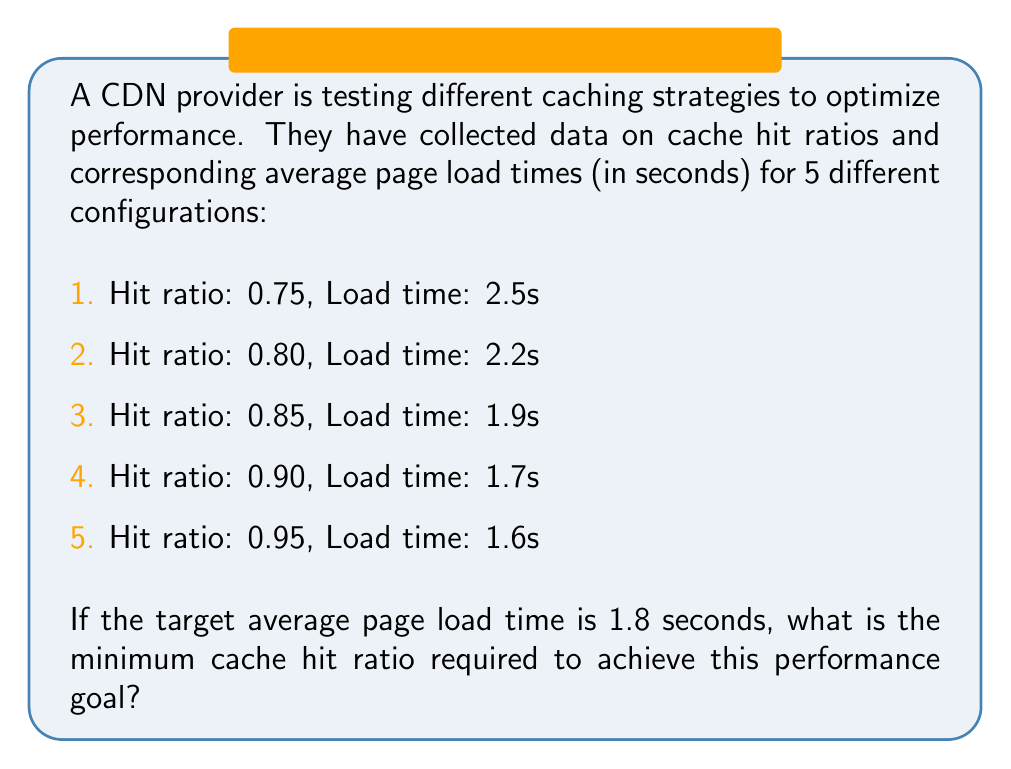What is the answer to this math problem? To solve this problem, we need to analyze the relationship between the cache hit ratio and the average page load time. Let's approach this step-by-step:

1. First, let's organize the data in ascending order of hit ratio:

   Hit Ratio (x) | Load Time (y)
   0.75          | 2.5s
   0.80          | 2.2s
   0.85          | 1.9s
   0.90          | 1.7s
   0.95          | 1.6s

2. We can see that as the hit ratio increases, the load time decreases. Our target load time is 1.8 seconds.

3. Looking at the data, we can see that a hit ratio of 0.85 gives a load time of 1.9s, which is just above our target, and a hit ratio of 0.90 gives a load time of 1.7s, which is just below our target.

4. This means our target hit ratio lies between 0.85 and 0.90.

5. To find the exact hit ratio, we can use linear interpolation between these two points:

   Let $x$ be the hit ratio we're looking for.
   
   We can set up the following equation:

   $$\frac{x - 0.85}{0.90 - 0.85} = \frac{1.8 - 1.9}{1.7 - 1.9}$$

6. Simplifying:

   $$\frac{x - 0.85}{0.05} = \frac{-0.1}{-0.2} = 0.5$$

7. Solving for $x$:

   $$x - 0.85 = 0.05 * 0.5 = 0.025$$
   $$x = 0.85 + 0.025 = 0.875$$

8. Therefore, the minimum cache hit ratio required to achieve an average page load time of 1.8 seconds is 0.875 or 87.5%.
Answer: 0.875 